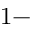Convert formula to latex. <formula><loc_0><loc_0><loc_500><loc_500>1 -</formula> 